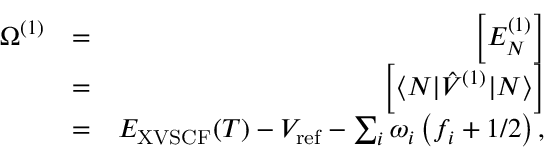<formula> <loc_0><loc_0><loc_500><loc_500>\begin{array} { r l r } { \Omega ^ { ( 1 ) } } & { = } & { \left [ E _ { N } ^ { ( 1 ) } \right ] } \\ & { = } & { \left [ \langle N | \hat { V } ^ { ( 1 ) } | N \rangle \right ] } \\ & { = } & { E _ { X V S C F } ( T ) - V _ { r e f } - \sum _ { i } { \omega } _ { i } \left ( f _ { i } + { 1 } / { 2 } \right ) , } \end{array}</formula> 